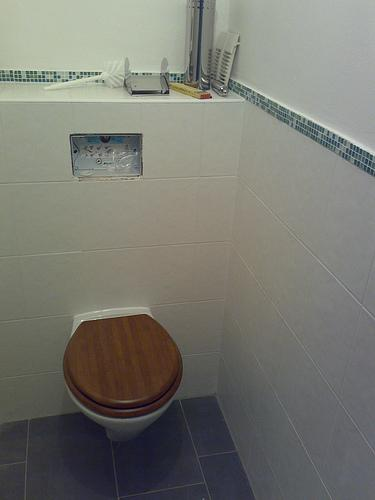Describe the image focusing on the colors and materials of the items within it. An off-white tiled wall surrounds a white toilet with a brown wooden seat, and a gray tiled floor, featuring a white toilet brush with a metal container on a shelf nearby. Explain the subject using adjectives for each object within the image. The image shows a pristine white toilet, brown wooden seat, smooth gray tiled floor, and a small rectangular hole on the white wall. Provide a concise overview of the significant elements in the image. A white toilet with a wooden seat is attached to a wall, on a blue-tiled floor, with a white toilet brush on a shelf and a hole in the wall above the toilet. Write a short description of the image, emphasizing the sanitary aspects. A clean white toilet with a closed lid is set against a tiled wall, adjacent to a shelf with a white toilet brush in a metal holder. Mention any unusual or distinct features of the main subject and its surroundings in the image. There is a hole in the wall above the toilet, which has a wooden seat, and the gray tiled floor has a large tile to the toilet's left. Describe the items connected to the wall, their colors, and usage in the image. A white toilet, brown wooden seat, small hole in the wall, and a shelf with a white toilet brush and ruler are featured in the scene. What are the primary aspects of the image that catch the viewer's attention? A white toilet with a wooden seat, a hole in the wall above, and a white brush on the shelf are the main focal points. Briefly explain the appearance of the floor in the photo. The floor consists of large grey and blue tiles, with a corner tile to the right of the toilet. Describe the main subject and the environment it is situated in within the image. A white toilet with a wood seat is positioned on a blue-gray tile floor, next to a shelf with various items, against a white tiled wall. Mention the primary feature and its unique attribute, along with two other noteworthy components in the image. A small toilet is attached directly to the wall, featuring a wooden seat, with a hole in the wall above it and a white brush on the shelf. 